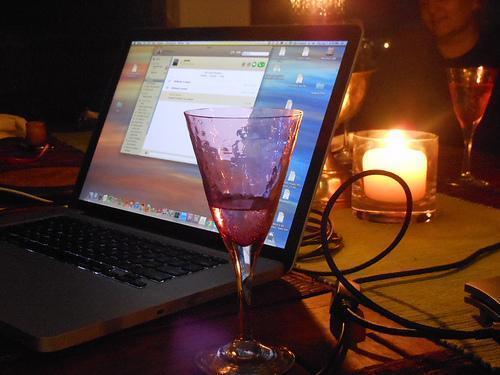How many people are in this picture?
Give a very brief answer. 1. 